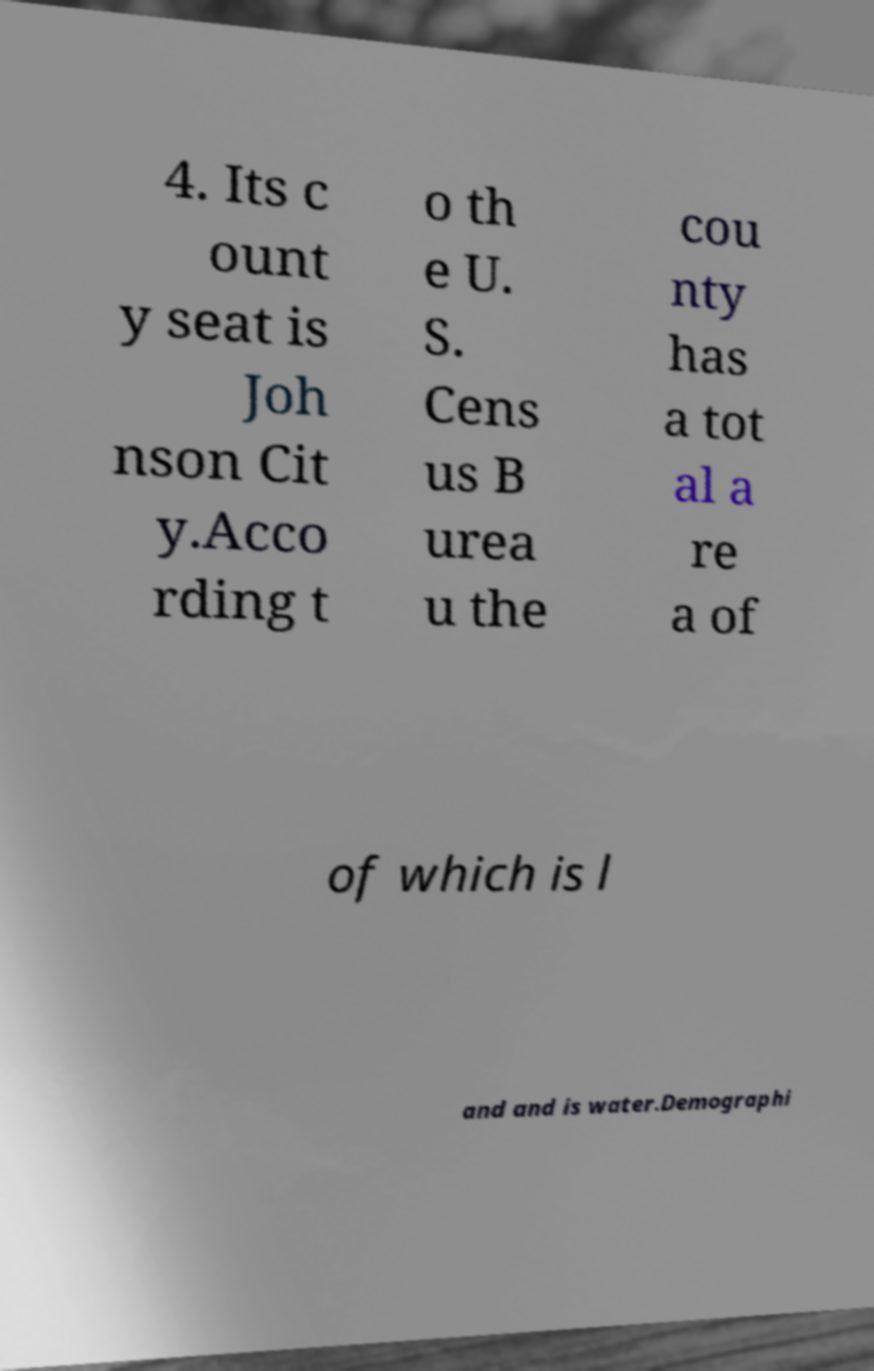Please identify and transcribe the text found in this image. 4. Its c ount y seat is Joh nson Cit y.Acco rding t o th e U. S. Cens us B urea u the cou nty has a tot al a re a of of which is l and and is water.Demographi 